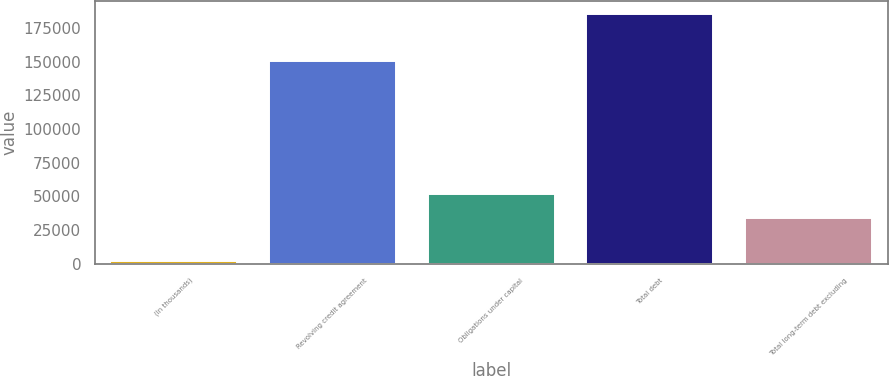Convert chart to OTSL. <chart><loc_0><loc_0><loc_500><loc_500><bar_chart><fcel>(In thousands)<fcel>Revolving credit agreement<fcel>Obligations under capital<fcel>Total debt<fcel>Total long-term debt excluding<nl><fcel>2007<fcel>150690<fcel>52091<fcel>185477<fcel>33744<nl></chart> 